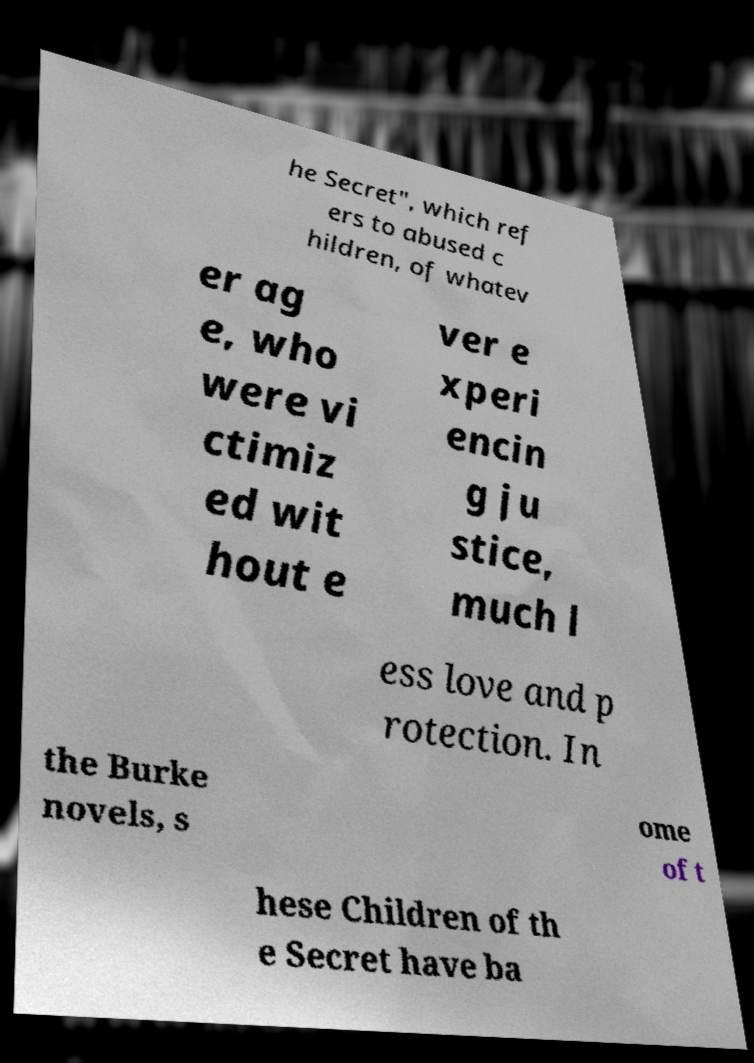I need the written content from this picture converted into text. Can you do that? he Secret", which ref ers to abused c hildren, of whatev er ag e, who were vi ctimiz ed wit hout e ver e xperi encin g ju stice, much l ess love and p rotection. In the Burke novels, s ome of t hese Children of th e Secret have ba 